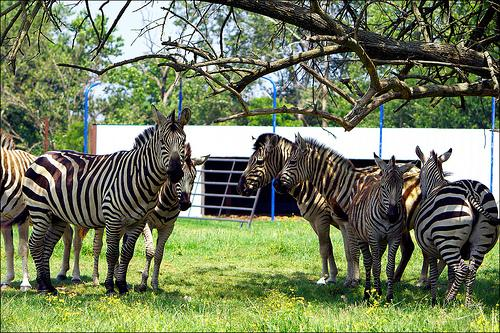What could be the main question for a multi-choice VQA task with this image? What is the main animal featured in this image? A) Giraffe B) Elephant C) Zebra D) Lion Choose one of the zebras and describe its position in the image. One of the zebras is positioned close to the white building, with its front and back legs visible, standing on the grass. Pick three main elements from the image and write a one-word description for each. Sky: blue. If this were an advertisement, what would the main message or the tagline be? "Experience the beauty of nature up close - visit our zebra exhibit today!" Mention the main animal spotted in the image and describe its features. The main animal in the image is a zebra, which has black and white stripes, a mane, round ears, and four legs. What type of animals are in the image, and what is their most distinctive feature? There are zebras in the image, and their most distinctive feature is their black and white striped pattern. Explain the setting in which the animals are found in this image. The zebras are found in a grassy meadow or field, possibly in a zoo or wildlife park, standing in the shade on a sunny day. Identify the main theme of the image and talk about any colors you see. The main theme of the image is a group of zebras in a natural setting. The dominant colors are black, white, and green from the zebras and the grass. What are some objects in the background or surroundings of the animals in this image? There is a white building, trees, metal blue poles, and a metal fence in the background or surroundings of the zebras. Describe a specific moment or action captured in this image. A baby zebra is standing in the grass, while a tail of another zebra can be seen swinging nearby. 